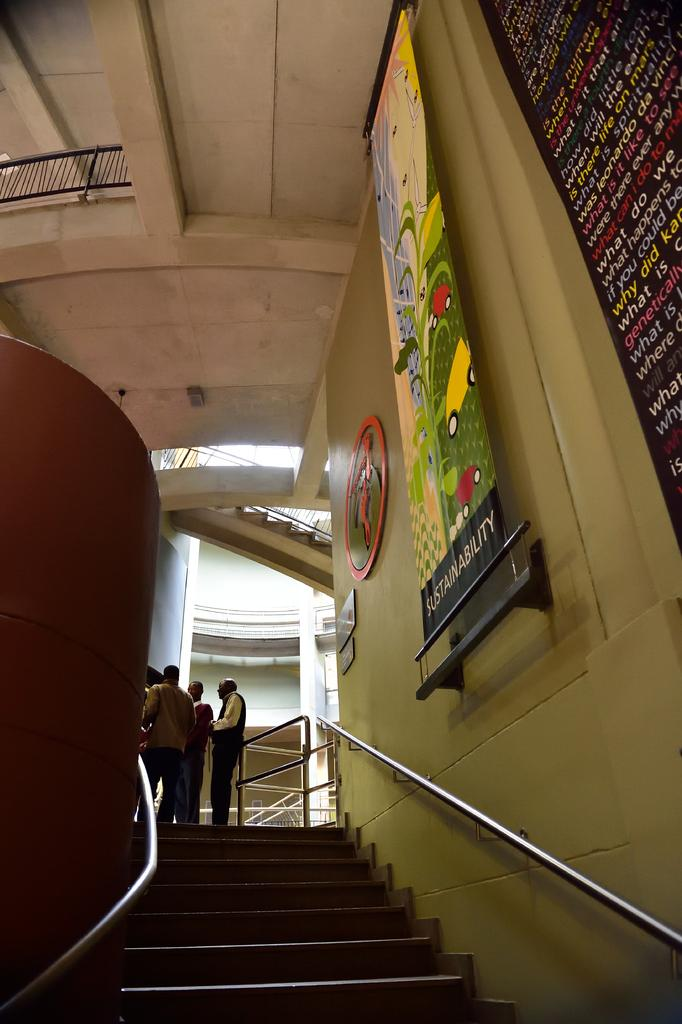What can be seen in the image that people use to move between different levels? There are stairs in the image that people use to move between different levels. What else is visible in the image besides the stairs? There are people standing in the image. What is attached to the wall in the background? There are banners attached to the wall in the background. What color is the wall in the image? The wall is in cream color. How many threads are used to create the fifth banner in the image? There is no mention of threads or banners in the image, and therefore no such information can be provided. 